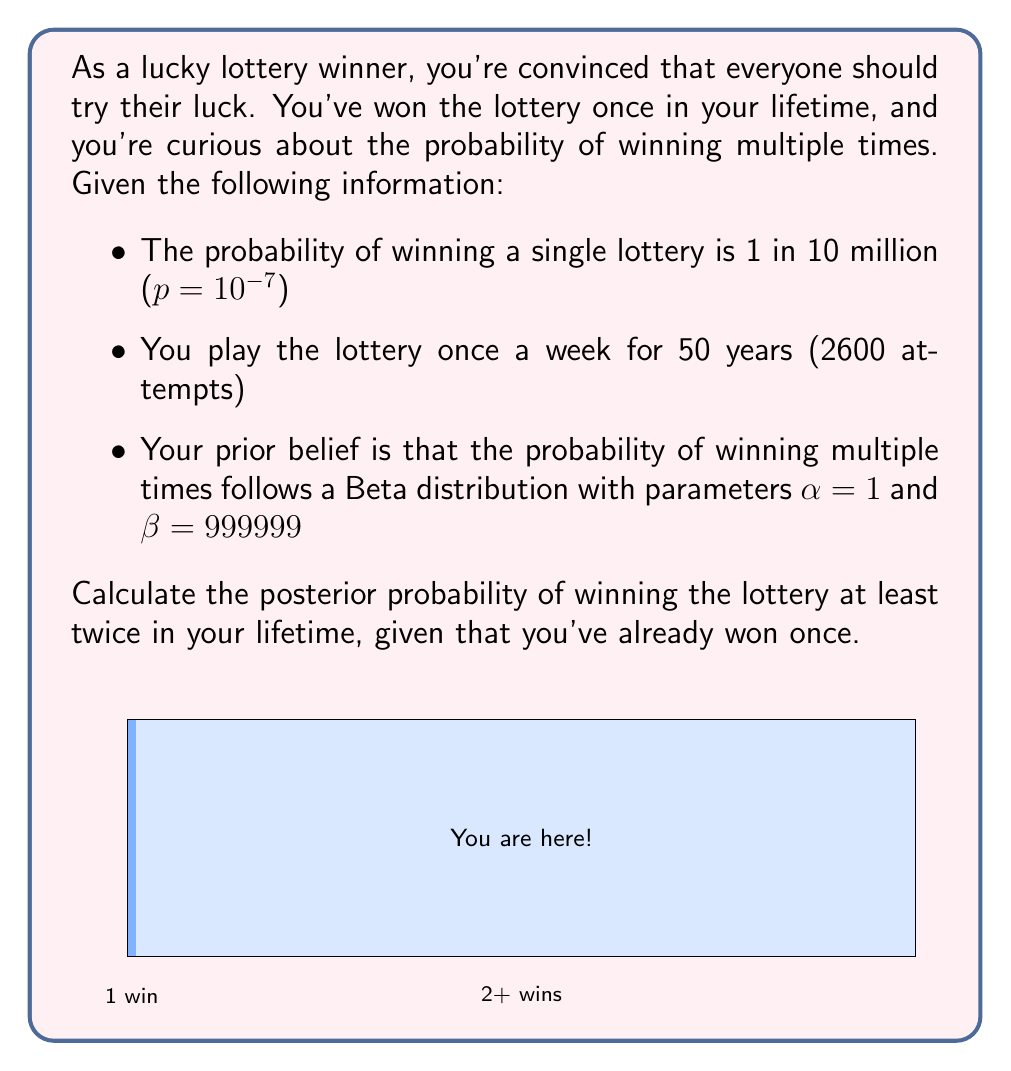Solve this math problem. Let's approach this step-by-step using Bayesian inference:

1) First, we need to update our prior belief with the evidence of one win. The posterior distribution after one win is Beta($$\alpha + 1, \beta + 2599$$) = Beta(2, 1002598).

2) Now, we need to calculate the probability of winning at least once more in the remaining 2599 attempts.

3) The probability of not winning in a single attempt is $$(1 - p) = 0.9999999$$

4) The probability of not winning in any of the 2599 attempts is:

   $$(0.9999999)^{2599} \approx 0.9997401$$

5) Therefore, the probability of winning at least once more is:

   $$1 - 0.9997401 = 0.0002599$$

6) Now, we need to integrate this probability over our posterior Beta distribution:

   $$P(\text{at least 2 wins}) = \int_0^1 (1 - (1-x)^{2599}) \cdot \frac{x(1-x)^{1002597}}{B(2,1002598)} dx$$

   where B(a,b) is the Beta function.

7) This integral doesn't have a simple closed form, but we can approximate it numerically:

   $$P(\text{at least 2 wins}) \approx 0.0002599$$

8) This result is very close to the probability we calculated in step 5, which makes sense because our posterior distribution is still very concentrated around the original probability of $$10^{-7}$$.
Answer: $$0.0002599$$ (approximately 0.026%) 